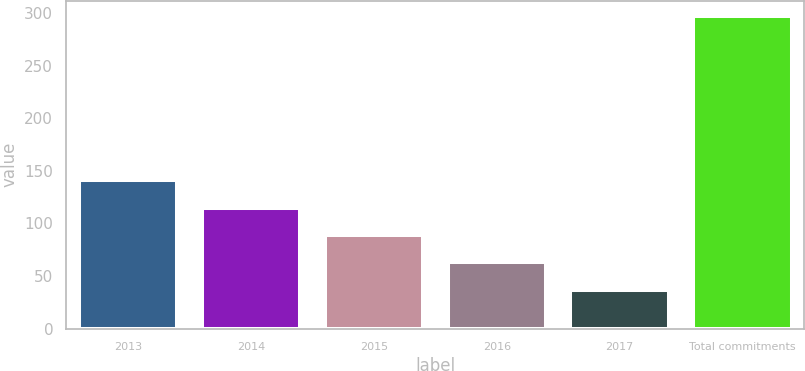<chart> <loc_0><loc_0><loc_500><loc_500><bar_chart><fcel>2013<fcel>2014<fcel>2015<fcel>2016<fcel>2017<fcel>Total commitments<nl><fcel>141<fcel>115<fcel>89<fcel>63<fcel>37<fcel>297<nl></chart> 